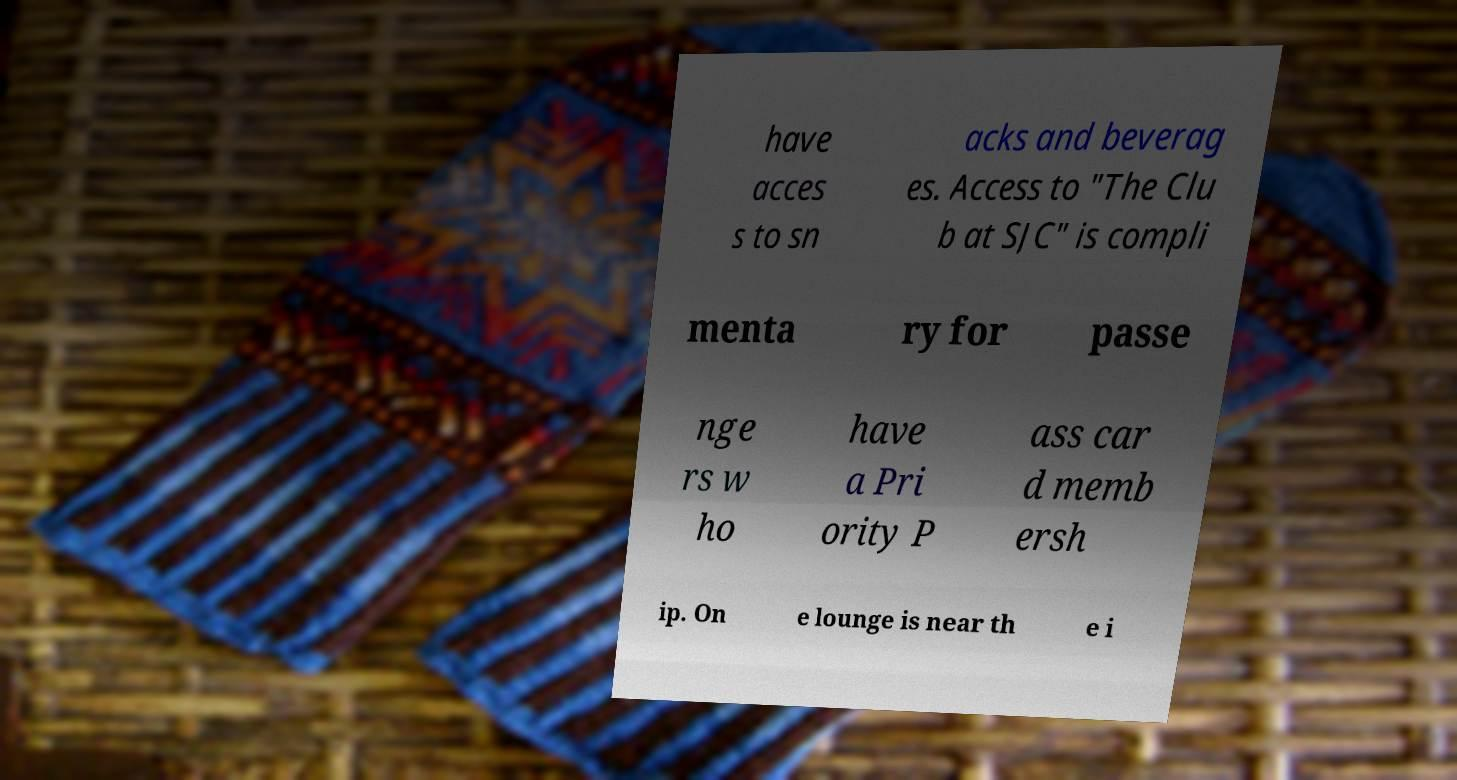Can you accurately transcribe the text from the provided image for me? have acces s to sn acks and beverag es. Access to "The Clu b at SJC" is compli menta ry for passe nge rs w ho have a Pri ority P ass car d memb ersh ip. On e lounge is near th e i 